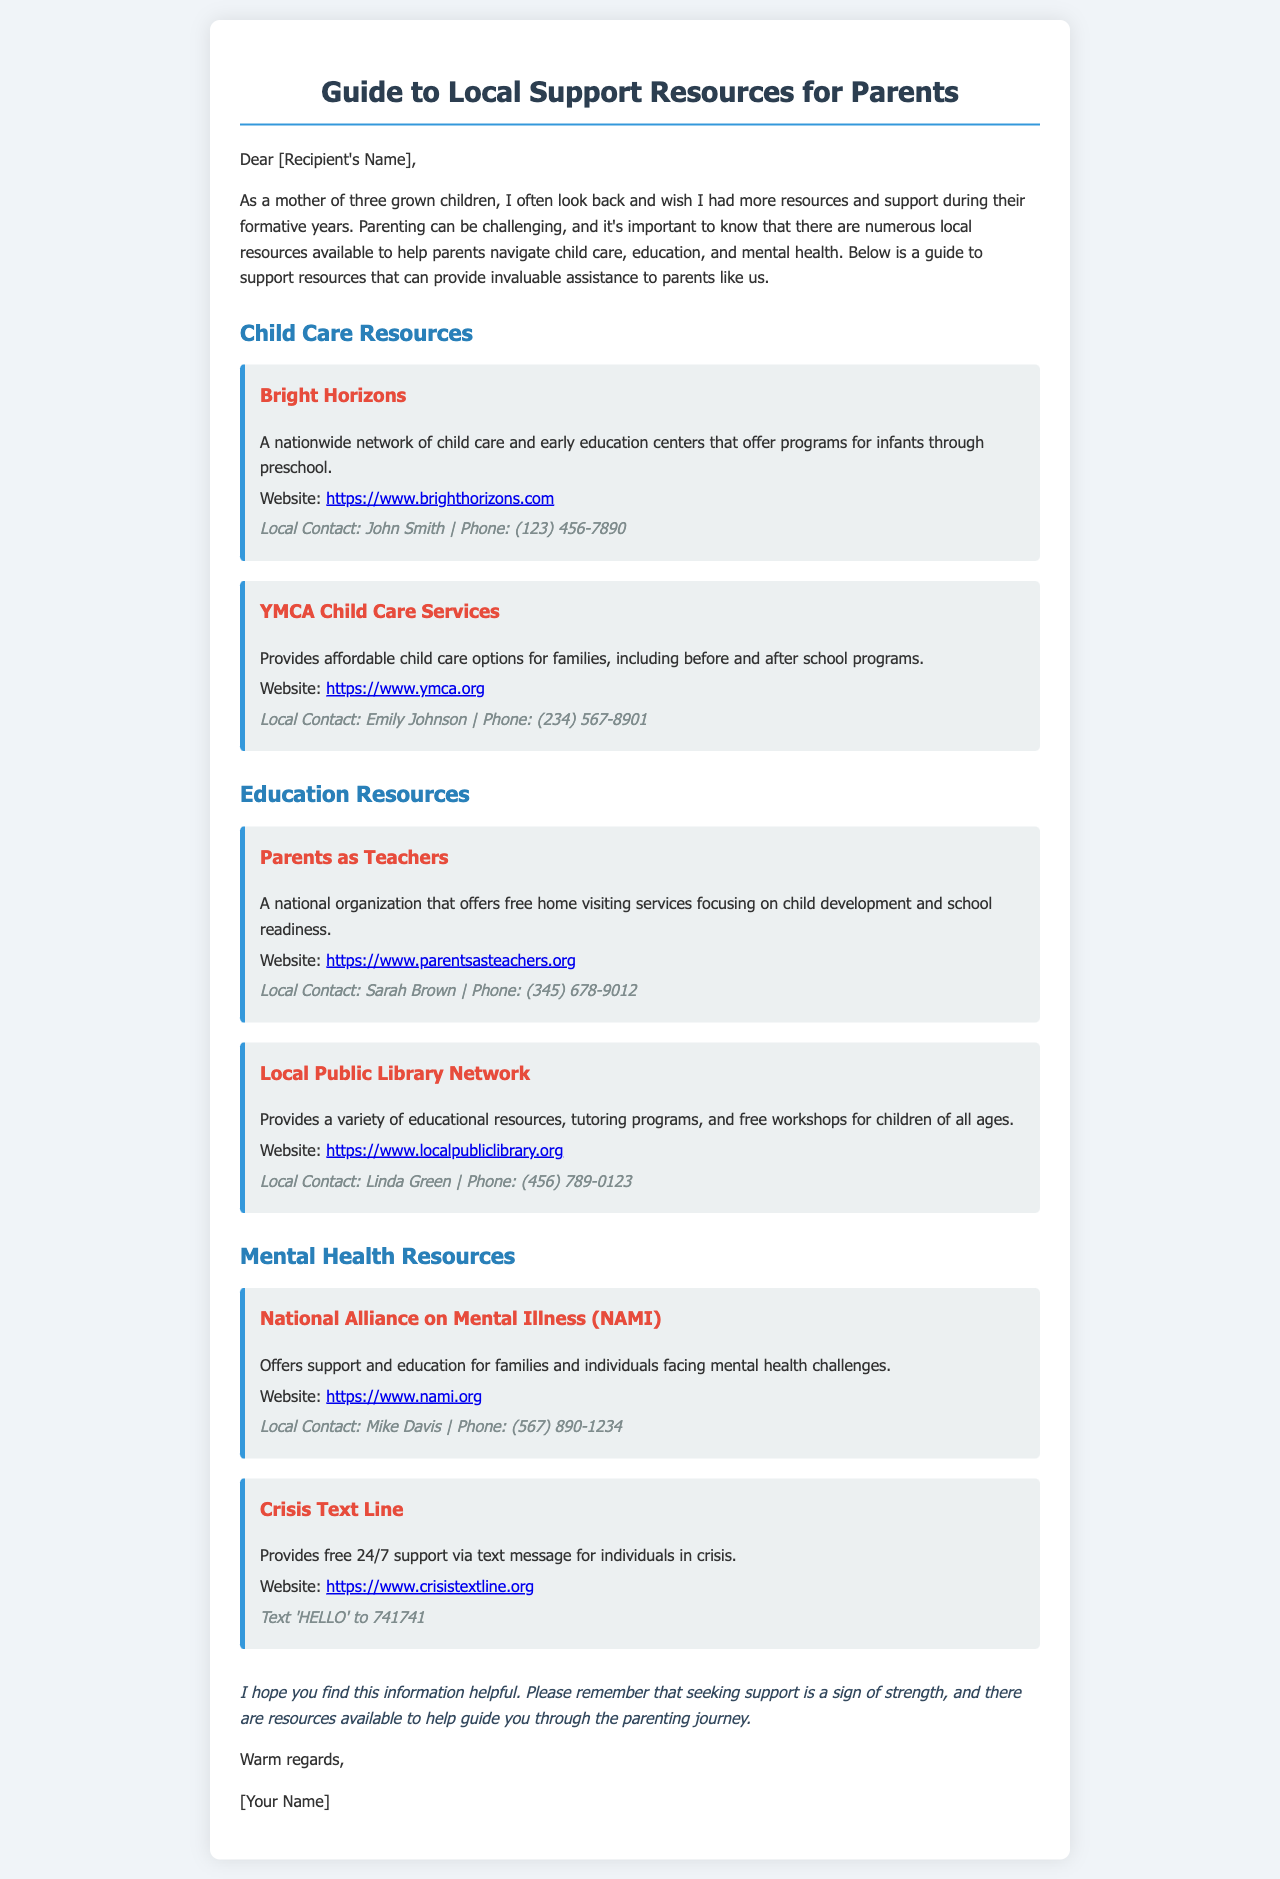what is the name of the child care resource that has a nationwide network? The document mentions "Bright Horizons" as a nationwide network of child care and early education centers.
Answer: Bright Horizons who should be contacted for YMCA Child Care Services? The contact person listed for YMCA Child Care Services is Emily Johnson.
Answer: Emily Johnson what is the website for Parents as Teachers? The document provides the URL for Parents as Teachers as part of the resource information.
Answer: https://www.parentsasteachers.org how can individuals reach the Crisis Text Line? The document states that individuals can reach the Crisis Text Line by texting 'HELLO' to a specific number.
Answer: Text 'HELLO' to 741741 what type of support does the National Alliance on Mental Illness (NAMI) provide? NAMI offers support and education for families and individuals facing mental health challenges, indicating a focus on educational support.
Answer: support and education how many resources are listed under Mental Health Resources? The document lists two resources specifically under the Mental Health section.
Answer: two what is the purpose of the Local Public Library Network? The Local Public Library Network aims to provide educational resources, tutoring programs, and free workshops for children.
Answer: educational resources what is the main topic of the document? The overall theme of the document is to provide local support resources for parents in various aspects of parenting.
Answer: support resources for parents 